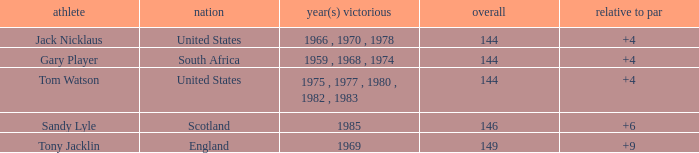What was Tom Watson's lowest To par when the total was larger than 144? None. 